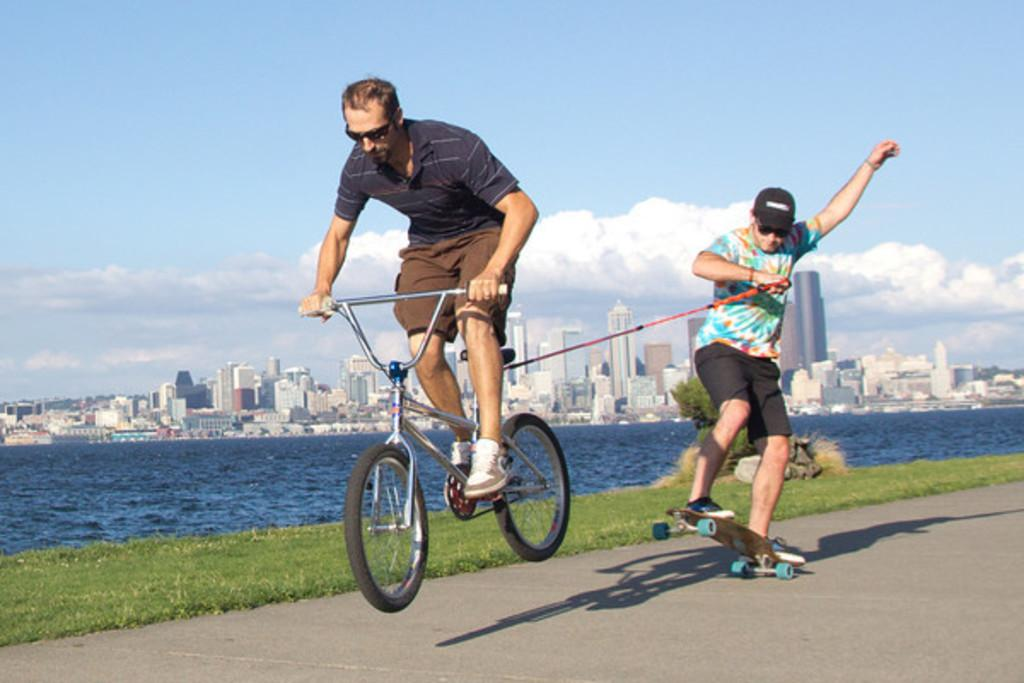How many people are in the image? There are two persons in the image. What are the two persons doing in the image? One person is riding a bicycle, and the other person is skating. Where are the two persons located in the image? They are on a road. What can be seen in the background of the image? There is water, a building, and the sky visible in the background of the image. What type of marble is being used to decorate the plant in the image? There is no marble or plant present in the image. What substance is being used to enhance the skating experience in the image? There is no mention of any substance being used to enhance the skating experience in the image. 